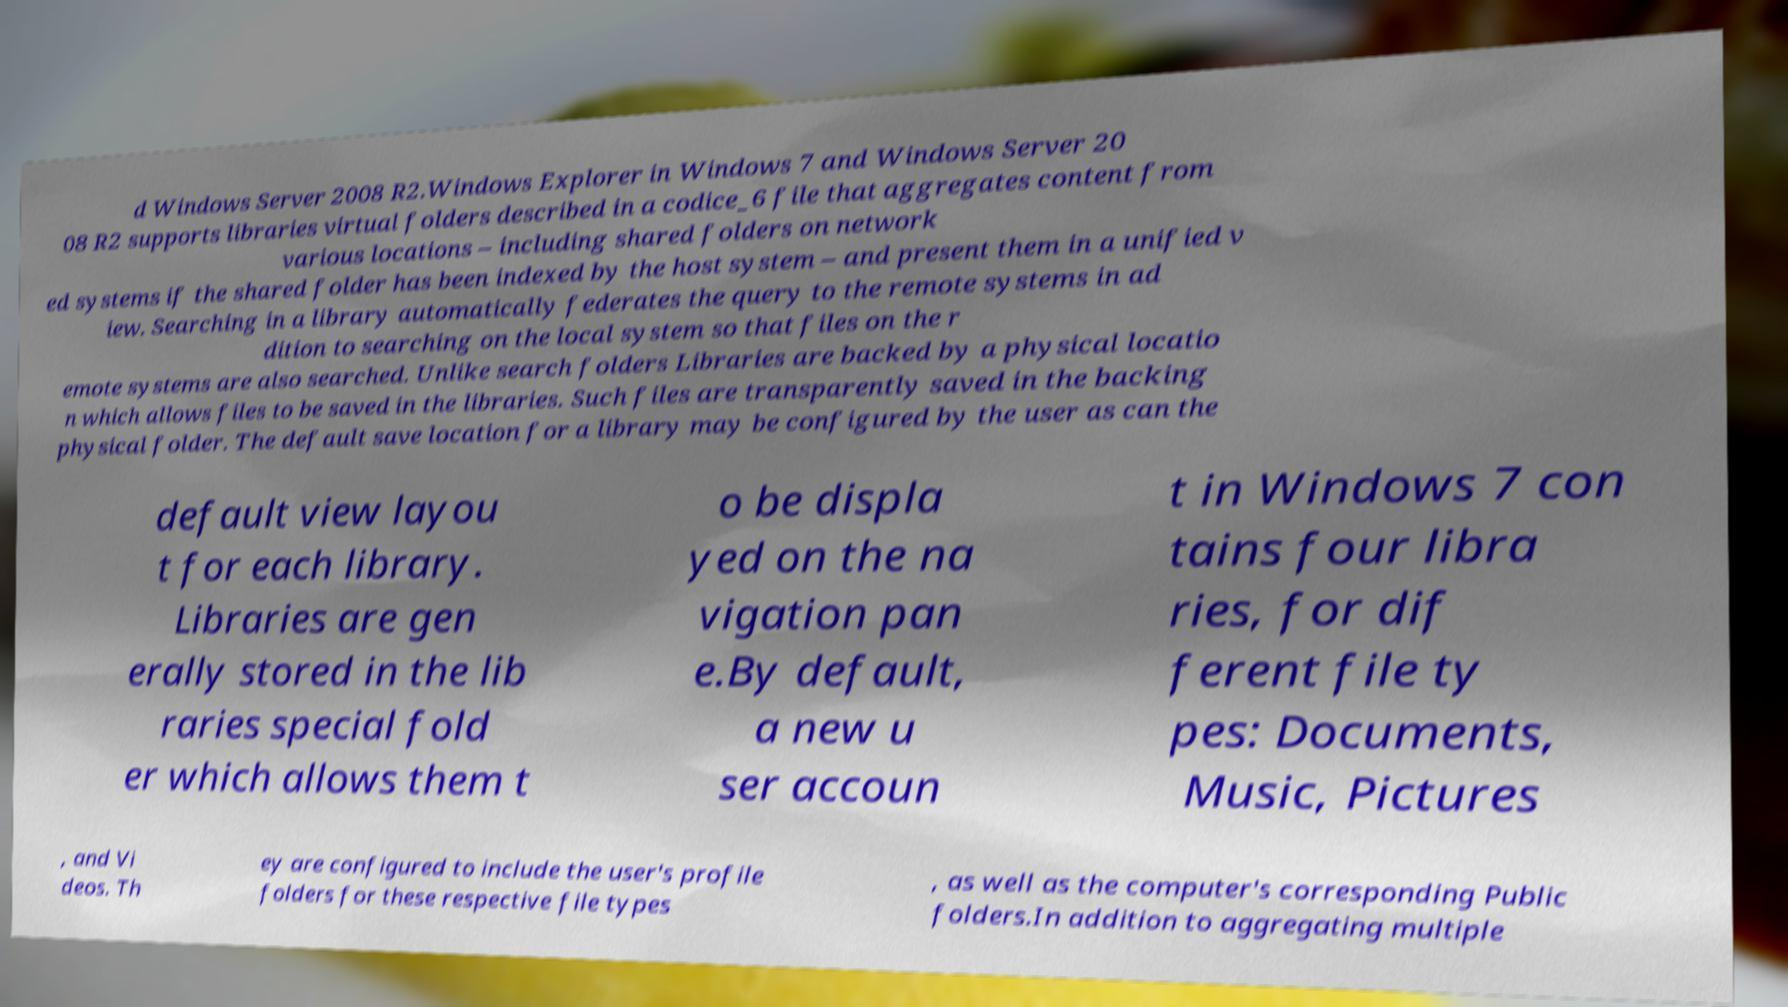Could you extract and type out the text from this image? d Windows Server 2008 R2.Windows Explorer in Windows 7 and Windows Server 20 08 R2 supports libraries virtual folders described in a codice_6 file that aggregates content from various locations – including shared folders on network ed systems if the shared folder has been indexed by the host system – and present them in a unified v iew. Searching in a library automatically federates the query to the remote systems in ad dition to searching on the local system so that files on the r emote systems are also searched. Unlike search folders Libraries are backed by a physical locatio n which allows files to be saved in the libraries. Such files are transparently saved in the backing physical folder. The default save location for a library may be configured by the user as can the default view layou t for each library. Libraries are gen erally stored in the lib raries special fold er which allows them t o be displa yed on the na vigation pan e.By default, a new u ser accoun t in Windows 7 con tains four libra ries, for dif ferent file ty pes: Documents, Music, Pictures , and Vi deos. Th ey are configured to include the user's profile folders for these respective file types , as well as the computer's corresponding Public folders.In addition to aggregating multiple 